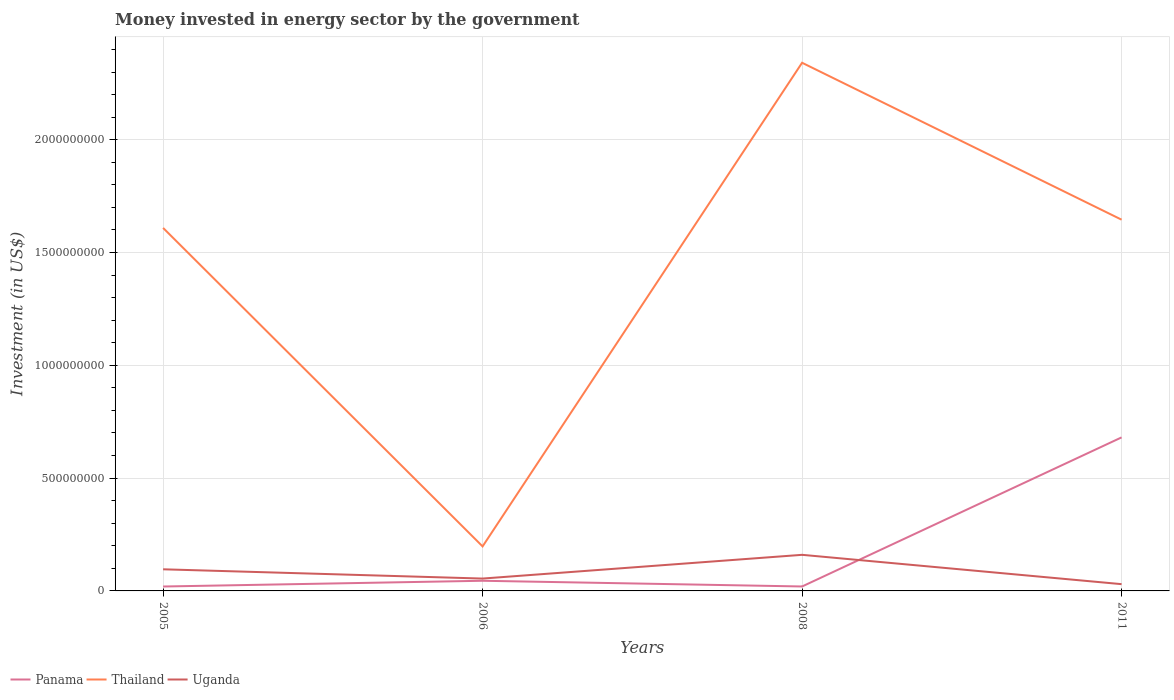How many different coloured lines are there?
Offer a terse response. 3. Does the line corresponding to Uganda intersect with the line corresponding to Thailand?
Make the answer very short. No. Across all years, what is the maximum money spent in energy sector in Panama?
Give a very brief answer. 1.95e+07. What is the total money spent in energy sector in Thailand in the graph?
Your answer should be compact. -1.45e+09. What is the difference between the highest and the second highest money spent in energy sector in Panama?
Your response must be concise. 6.61e+08. What is the difference between the highest and the lowest money spent in energy sector in Thailand?
Your answer should be very brief. 3. How many years are there in the graph?
Your answer should be compact. 4. Does the graph contain any zero values?
Your answer should be very brief. No. Does the graph contain grids?
Give a very brief answer. Yes. Where does the legend appear in the graph?
Keep it short and to the point. Bottom left. How are the legend labels stacked?
Make the answer very short. Horizontal. What is the title of the graph?
Your answer should be very brief. Money invested in energy sector by the government. What is the label or title of the X-axis?
Your response must be concise. Years. What is the label or title of the Y-axis?
Give a very brief answer. Investment (in US$). What is the Investment (in US$) of Panama in 2005?
Ensure brevity in your answer.  1.95e+07. What is the Investment (in US$) of Thailand in 2005?
Offer a very short reply. 1.61e+09. What is the Investment (in US$) of Uganda in 2005?
Provide a succinct answer. 9.58e+07. What is the Investment (in US$) in Panama in 2006?
Keep it short and to the point. 4.50e+07. What is the Investment (in US$) in Thailand in 2006?
Keep it short and to the point. 1.97e+08. What is the Investment (in US$) of Uganda in 2006?
Provide a short and direct response. 5.48e+07. What is the Investment (in US$) in Panama in 2008?
Make the answer very short. 1.97e+07. What is the Investment (in US$) in Thailand in 2008?
Give a very brief answer. 2.34e+09. What is the Investment (in US$) of Uganda in 2008?
Keep it short and to the point. 1.60e+08. What is the Investment (in US$) of Panama in 2011?
Your answer should be compact. 6.80e+08. What is the Investment (in US$) of Thailand in 2011?
Provide a short and direct response. 1.65e+09. What is the Investment (in US$) of Uganda in 2011?
Give a very brief answer. 3.00e+07. Across all years, what is the maximum Investment (in US$) of Panama?
Offer a very short reply. 6.80e+08. Across all years, what is the maximum Investment (in US$) in Thailand?
Offer a terse response. 2.34e+09. Across all years, what is the maximum Investment (in US$) of Uganda?
Provide a succinct answer. 1.60e+08. Across all years, what is the minimum Investment (in US$) in Panama?
Your answer should be very brief. 1.95e+07. Across all years, what is the minimum Investment (in US$) in Thailand?
Ensure brevity in your answer.  1.97e+08. Across all years, what is the minimum Investment (in US$) in Uganda?
Your response must be concise. 3.00e+07. What is the total Investment (in US$) of Panama in the graph?
Offer a terse response. 7.65e+08. What is the total Investment (in US$) of Thailand in the graph?
Keep it short and to the point. 5.79e+09. What is the total Investment (in US$) in Uganda in the graph?
Your answer should be compact. 3.41e+08. What is the difference between the Investment (in US$) of Panama in 2005 and that in 2006?
Keep it short and to the point. -2.55e+07. What is the difference between the Investment (in US$) of Thailand in 2005 and that in 2006?
Offer a terse response. 1.41e+09. What is the difference between the Investment (in US$) of Uganda in 2005 and that in 2006?
Your answer should be very brief. 4.10e+07. What is the difference between the Investment (in US$) of Panama in 2005 and that in 2008?
Your answer should be very brief. -2.00e+05. What is the difference between the Investment (in US$) of Thailand in 2005 and that in 2008?
Your answer should be very brief. -7.32e+08. What is the difference between the Investment (in US$) of Uganda in 2005 and that in 2008?
Your response must be concise. -6.42e+07. What is the difference between the Investment (in US$) in Panama in 2005 and that in 2011?
Offer a very short reply. -6.61e+08. What is the difference between the Investment (in US$) in Thailand in 2005 and that in 2011?
Ensure brevity in your answer.  -3.65e+07. What is the difference between the Investment (in US$) in Uganda in 2005 and that in 2011?
Provide a succinct answer. 6.58e+07. What is the difference between the Investment (in US$) of Panama in 2006 and that in 2008?
Give a very brief answer. 2.53e+07. What is the difference between the Investment (in US$) of Thailand in 2006 and that in 2008?
Offer a very short reply. -2.14e+09. What is the difference between the Investment (in US$) in Uganda in 2006 and that in 2008?
Ensure brevity in your answer.  -1.05e+08. What is the difference between the Investment (in US$) in Panama in 2006 and that in 2011?
Your answer should be compact. -6.36e+08. What is the difference between the Investment (in US$) of Thailand in 2006 and that in 2011?
Make the answer very short. -1.45e+09. What is the difference between the Investment (in US$) of Uganda in 2006 and that in 2011?
Provide a short and direct response. 2.48e+07. What is the difference between the Investment (in US$) in Panama in 2008 and that in 2011?
Make the answer very short. -6.61e+08. What is the difference between the Investment (in US$) of Thailand in 2008 and that in 2011?
Keep it short and to the point. 6.96e+08. What is the difference between the Investment (in US$) in Uganda in 2008 and that in 2011?
Offer a very short reply. 1.30e+08. What is the difference between the Investment (in US$) in Panama in 2005 and the Investment (in US$) in Thailand in 2006?
Offer a very short reply. -1.78e+08. What is the difference between the Investment (in US$) in Panama in 2005 and the Investment (in US$) in Uganda in 2006?
Your answer should be very brief. -3.53e+07. What is the difference between the Investment (in US$) of Thailand in 2005 and the Investment (in US$) of Uganda in 2006?
Provide a short and direct response. 1.55e+09. What is the difference between the Investment (in US$) of Panama in 2005 and the Investment (in US$) of Thailand in 2008?
Keep it short and to the point. -2.32e+09. What is the difference between the Investment (in US$) in Panama in 2005 and the Investment (in US$) in Uganda in 2008?
Keep it short and to the point. -1.40e+08. What is the difference between the Investment (in US$) of Thailand in 2005 and the Investment (in US$) of Uganda in 2008?
Your answer should be compact. 1.45e+09. What is the difference between the Investment (in US$) in Panama in 2005 and the Investment (in US$) in Thailand in 2011?
Provide a short and direct response. -1.63e+09. What is the difference between the Investment (in US$) of Panama in 2005 and the Investment (in US$) of Uganda in 2011?
Ensure brevity in your answer.  -1.05e+07. What is the difference between the Investment (in US$) of Thailand in 2005 and the Investment (in US$) of Uganda in 2011?
Offer a terse response. 1.58e+09. What is the difference between the Investment (in US$) of Panama in 2006 and the Investment (in US$) of Thailand in 2008?
Provide a short and direct response. -2.30e+09. What is the difference between the Investment (in US$) in Panama in 2006 and the Investment (in US$) in Uganda in 2008?
Offer a terse response. -1.15e+08. What is the difference between the Investment (in US$) of Thailand in 2006 and the Investment (in US$) of Uganda in 2008?
Ensure brevity in your answer.  3.73e+07. What is the difference between the Investment (in US$) of Panama in 2006 and the Investment (in US$) of Thailand in 2011?
Offer a terse response. -1.60e+09. What is the difference between the Investment (in US$) of Panama in 2006 and the Investment (in US$) of Uganda in 2011?
Offer a very short reply. 1.50e+07. What is the difference between the Investment (in US$) in Thailand in 2006 and the Investment (in US$) in Uganda in 2011?
Your response must be concise. 1.67e+08. What is the difference between the Investment (in US$) of Panama in 2008 and the Investment (in US$) of Thailand in 2011?
Your answer should be very brief. -1.63e+09. What is the difference between the Investment (in US$) of Panama in 2008 and the Investment (in US$) of Uganda in 2011?
Provide a succinct answer. -1.03e+07. What is the difference between the Investment (in US$) in Thailand in 2008 and the Investment (in US$) in Uganda in 2011?
Offer a very short reply. 2.31e+09. What is the average Investment (in US$) in Panama per year?
Offer a very short reply. 1.91e+08. What is the average Investment (in US$) of Thailand per year?
Offer a very short reply. 1.45e+09. What is the average Investment (in US$) in Uganda per year?
Offer a very short reply. 8.52e+07. In the year 2005, what is the difference between the Investment (in US$) in Panama and Investment (in US$) in Thailand?
Make the answer very short. -1.59e+09. In the year 2005, what is the difference between the Investment (in US$) of Panama and Investment (in US$) of Uganda?
Make the answer very short. -7.63e+07. In the year 2005, what is the difference between the Investment (in US$) of Thailand and Investment (in US$) of Uganda?
Make the answer very short. 1.51e+09. In the year 2006, what is the difference between the Investment (in US$) in Panama and Investment (in US$) in Thailand?
Your response must be concise. -1.52e+08. In the year 2006, what is the difference between the Investment (in US$) of Panama and Investment (in US$) of Uganda?
Your response must be concise. -9.80e+06. In the year 2006, what is the difference between the Investment (in US$) in Thailand and Investment (in US$) in Uganda?
Offer a very short reply. 1.42e+08. In the year 2008, what is the difference between the Investment (in US$) in Panama and Investment (in US$) in Thailand?
Make the answer very short. -2.32e+09. In the year 2008, what is the difference between the Investment (in US$) in Panama and Investment (in US$) in Uganda?
Your answer should be very brief. -1.40e+08. In the year 2008, what is the difference between the Investment (in US$) of Thailand and Investment (in US$) of Uganda?
Provide a succinct answer. 2.18e+09. In the year 2011, what is the difference between the Investment (in US$) in Panama and Investment (in US$) in Thailand?
Offer a very short reply. -9.65e+08. In the year 2011, what is the difference between the Investment (in US$) in Panama and Investment (in US$) in Uganda?
Make the answer very short. 6.50e+08. In the year 2011, what is the difference between the Investment (in US$) in Thailand and Investment (in US$) in Uganda?
Your response must be concise. 1.62e+09. What is the ratio of the Investment (in US$) of Panama in 2005 to that in 2006?
Your response must be concise. 0.43. What is the ratio of the Investment (in US$) in Thailand in 2005 to that in 2006?
Give a very brief answer. 8.16. What is the ratio of the Investment (in US$) of Uganda in 2005 to that in 2006?
Give a very brief answer. 1.75. What is the ratio of the Investment (in US$) of Thailand in 2005 to that in 2008?
Your response must be concise. 0.69. What is the ratio of the Investment (in US$) of Uganda in 2005 to that in 2008?
Your response must be concise. 0.6. What is the ratio of the Investment (in US$) in Panama in 2005 to that in 2011?
Your answer should be very brief. 0.03. What is the ratio of the Investment (in US$) of Thailand in 2005 to that in 2011?
Your answer should be very brief. 0.98. What is the ratio of the Investment (in US$) of Uganda in 2005 to that in 2011?
Your response must be concise. 3.19. What is the ratio of the Investment (in US$) of Panama in 2006 to that in 2008?
Make the answer very short. 2.28. What is the ratio of the Investment (in US$) in Thailand in 2006 to that in 2008?
Give a very brief answer. 0.08. What is the ratio of the Investment (in US$) of Uganda in 2006 to that in 2008?
Your answer should be very brief. 0.34. What is the ratio of the Investment (in US$) of Panama in 2006 to that in 2011?
Offer a terse response. 0.07. What is the ratio of the Investment (in US$) of Thailand in 2006 to that in 2011?
Offer a very short reply. 0.12. What is the ratio of the Investment (in US$) of Uganda in 2006 to that in 2011?
Keep it short and to the point. 1.83. What is the ratio of the Investment (in US$) of Panama in 2008 to that in 2011?
Ensure brevity in your answer.  0.03. What is the ratio of the Investment (in US$) in Thailand in 2008 to that in 2011?
Provide a short and direct response. 1.42. What is the ratio of the Investment (in US$) of Uganda in 2008 to that in 2011?
Give a very brief answer. 5.33. What is the difference between the highest and the second highest Investment (in US$) in Panama?
Ensure brevity in your answer.  6.36e+08. What is the difference between the highest and the second highest Investment (in US$) of Thailand?
Your response must be concise. 6.96e+08. What is the difference between the highest and the second highest Investment (in US$) in Uganda?
Provide a short and direct response. 6.42e+07. What is the difference between the highest and the lowest Investment (in US$) of Panama?
Provide a short and direct response. 6.61e+08. What is the difference between the highest and the lowest Investment (in US$) of Thailand?
Your answer should be very brief. 2.14e+09. What is the difference between the highest and the lowest Investment (in US$) of Uganda?
Keep it short and to the point. 1.30e+08. 